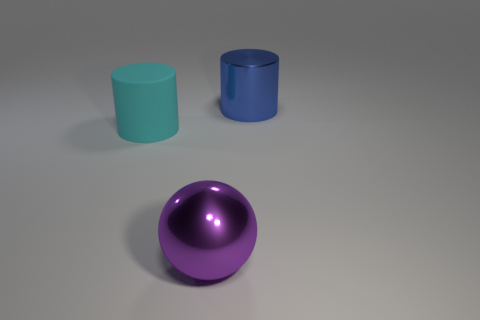Add 2 purple balls. How many objects exist? 5 Subtract all cyan cylinders. How many cylinders are left? 1 Subtract all cylinders. How many objects are left? 1 Subtract 0 brown cylinders. How many objects are left? 3 Subtract all green cylinders. Subtract all yellow spheres. How many cylinders are left? 2 Subtract all big gray matte things. Subtract all big cyan cylinders. How many objects are left? 2 Add 3 blue metallic things. How many blue metallic things are left? 4 Add 1 cyan matte cylinders. How many cyan matte cylinders exist? 2 